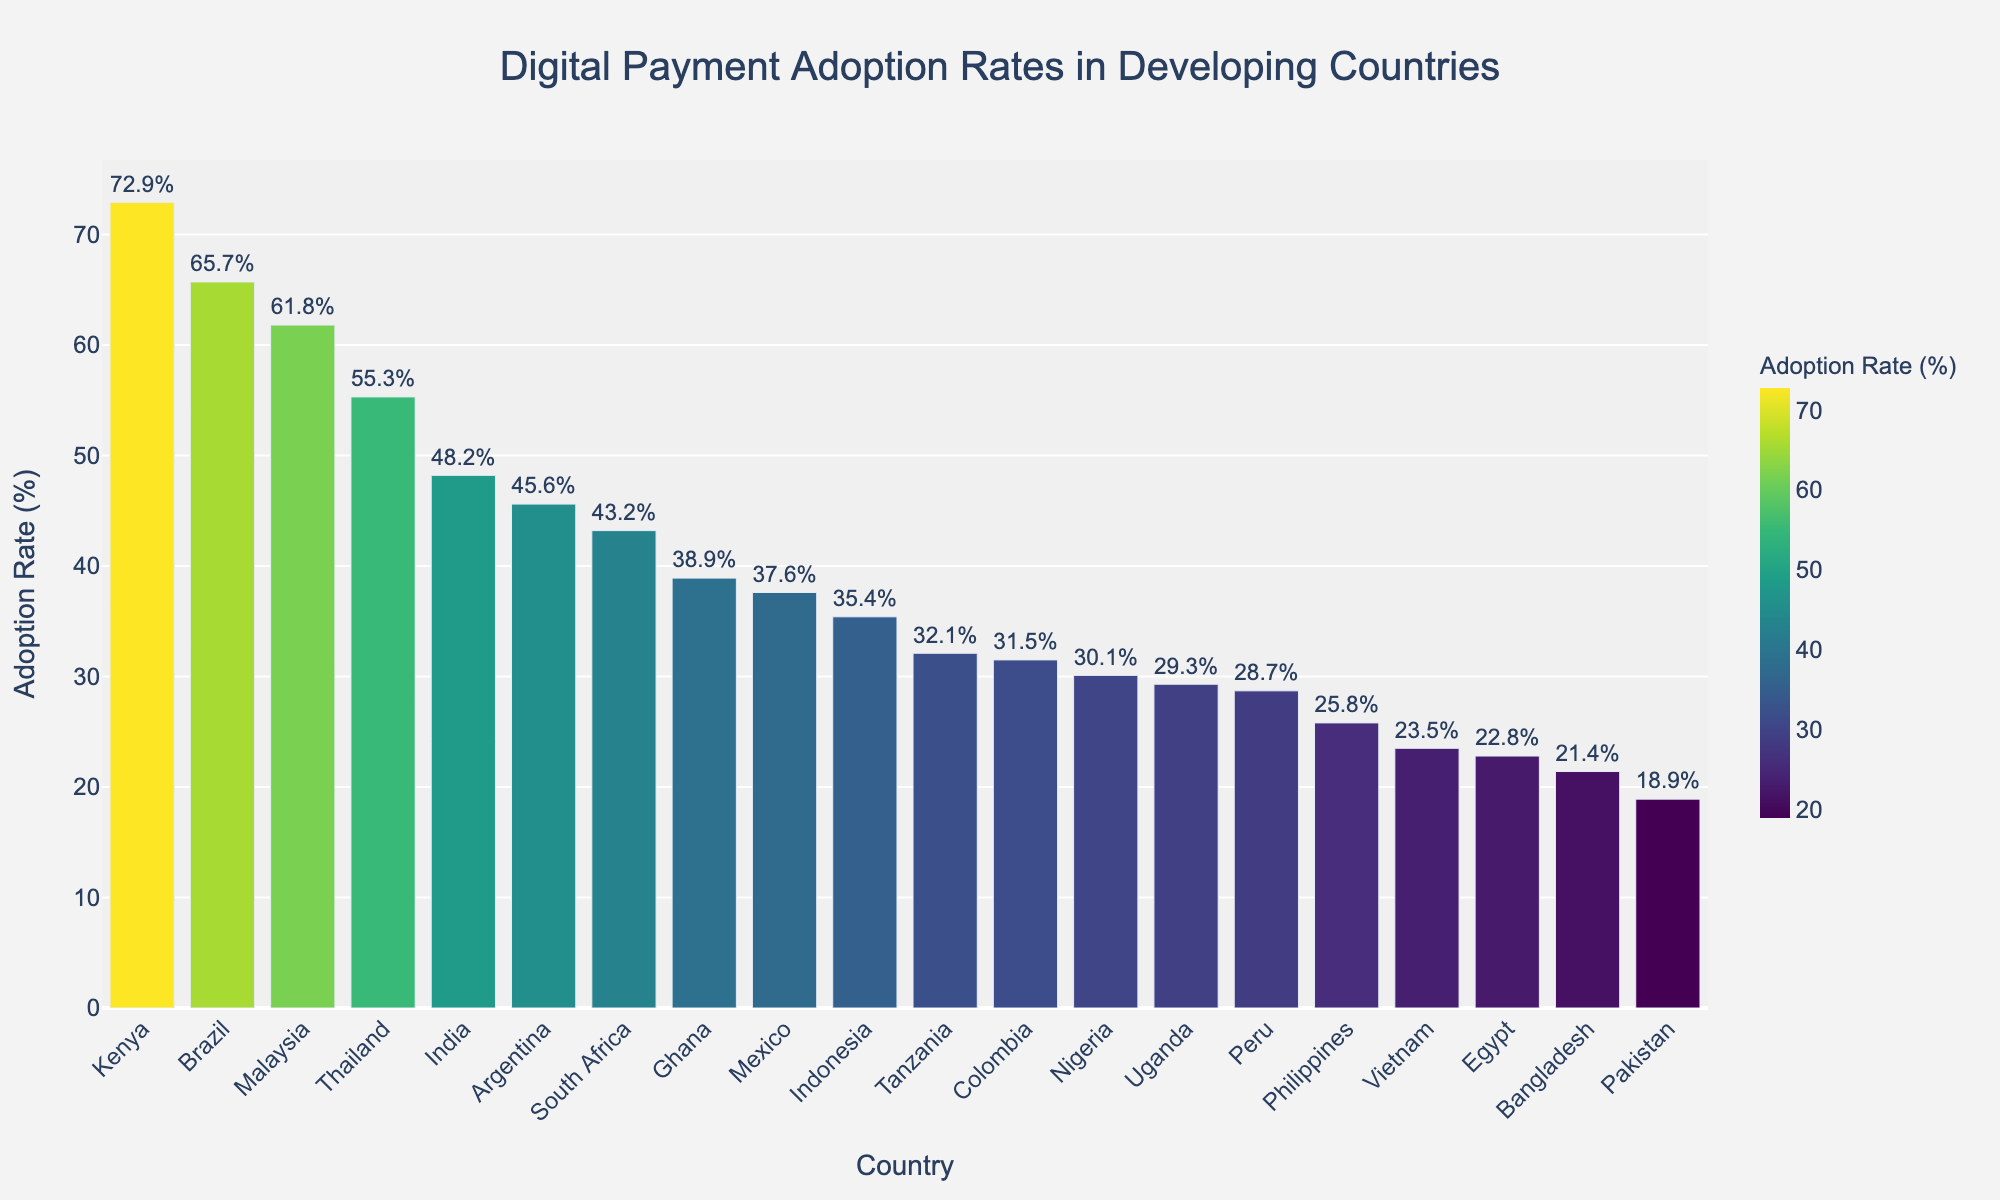Which country has the highest adoption rate of digital payment methods? The bar chart shows the adoption rates of various countries, and we can see from the height and color of the bars that Kenya has the highest adoption rate.
Answer: Kenya What is the difference in digital payment adoption rates between Kenya and Vietnam? From the chart, Kenya has an adoption rate of 72.9%, and Vietnam has an adoption rate of 23.5%. The difference is 72.9% - 23.5% = 49.4%.
Answer: 49.4% How many countries have a digital payment adoption rate of over 50%? By visually scanning the bars in the chart, we see that the countries with adoption rates over 50% are Kenya, Brazil, Thailand, and Malaysia. Therefore, there are 4 countries in total.
Answer: 4 What is the average digital payment adoption rate of India, Indonesia, and Nigeria? The adoption rates are: India (48.2%), Indonesia (35.4%), and Nigeria (30.1%). The average is calculated as (48.2 + 35.4 + 30.1) / 3 = 37.9%.
Answer: 37.9% Which country has an adoption rate lower than both Argentina and Peru but higher than Egypt? Argentina has an adoption rate of 45.6%, Peru has 28.7%, and Egypt has 22.8%. Scanning the chart, Colombia has an adoption rate of 31.5%, which fits this criteria.
Answer: Colombia Which countries have a digital payment adoption rate near the median value? To find the median, arrange the rates in ascending order and find the middle value. Ordered: 18.9, 21.4, 22.8, 23.5, 25.8, 28.7, 29.3, 30.1, 31.5, 32.1, 35.4, 37.6, 38.9, 43.2, 45.6, 48.2, 55.3, 61.8, 65.7, 72.9. The median is the average of the 10th and 11th values: (31.5% + 32.1%) / 2 = 31.8%. Tanzania and Colombia have rates close to this median.
Answer: Tanzania, Colombia What percent higher is Kenya's adoption rate compared to Bangladesh's? Kenya's rate is 72.9% and Bangladesh's is 21.4%. The difference is 72.9% - 21.4% = 51.5%, so Kenya’s adoption rate is 51.5% higher.
Answer: 51.5% 